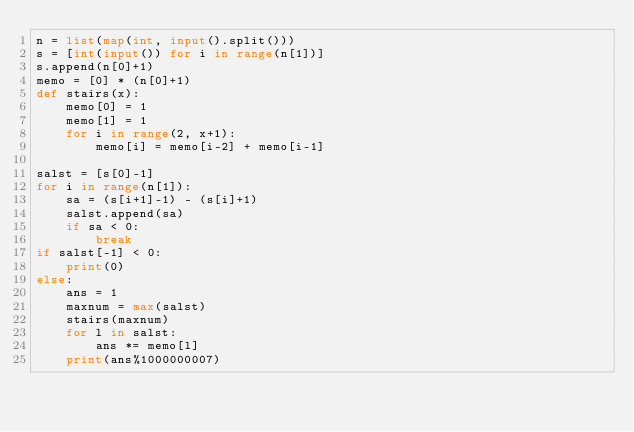<code> <loc_0><loc_0><loc_500><loc_500><_Python_>n = list(map(int, input().split()))
s = [int(input()) for i in range(n[1])]
s.append(n[0]+1)
memo = [0] * (n[0]+1)
def stairs(x):
    memo[0] = 1
    memo[1] = 1
    for i in range(2, x+1):
        memo[i] = memo[i-2] + memo[i-1]

salst = [s[0]-1]
for i in range(n[1]):
    sa = (s[i+1]-1) - (s[i]+1)
    salst.append(sa)
    if sa < 0:
        break
if salst[-1] < 0:
    print(0)
else:
    ans = 1
    maxnum = max(salst)
    stairs(maxnum)
    for l in salst:
        ans *= memo[l]
    print(ans%1000000007)
</code> 